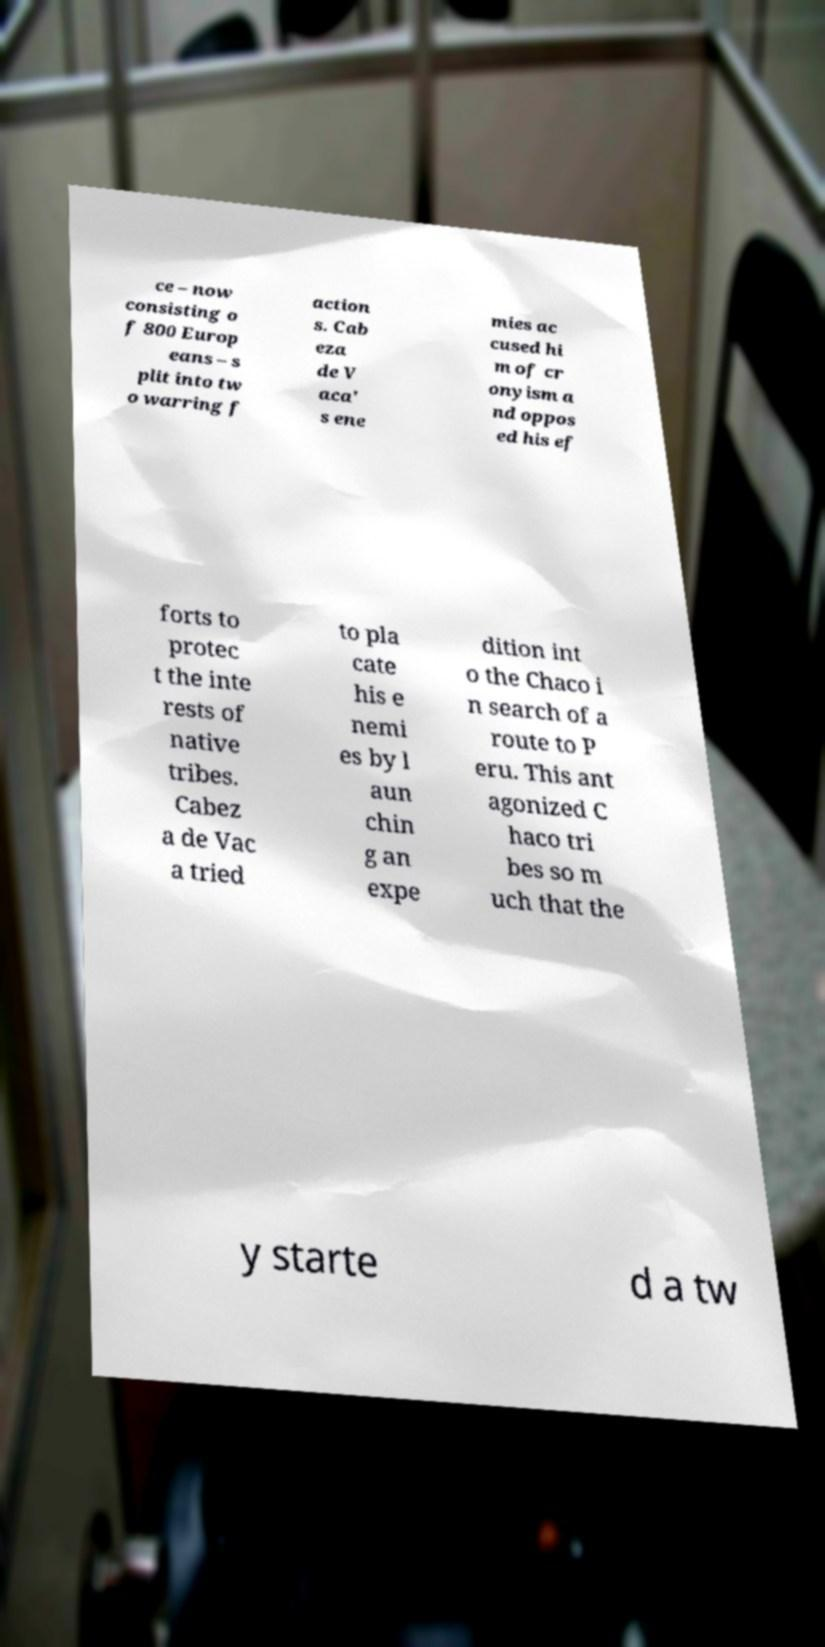Could you assist in decoding the text presented in this image and type it out clearly? ce – now consisting o f 800 Europ eans – s plit into tw o warring f action s. Cab eza de V aca' s ene mies ac cused hi m of cr onyism a nd oppos ed his ef forts to protec t the inte rests of native tribes. Cabez a de Vac a tried to pla cate his e nemi es by l aun chin g an expe dition int o the Chaco i n search of a route to P eru. This ant agonized C haco tri bes so m uch that the y starte d a tw 